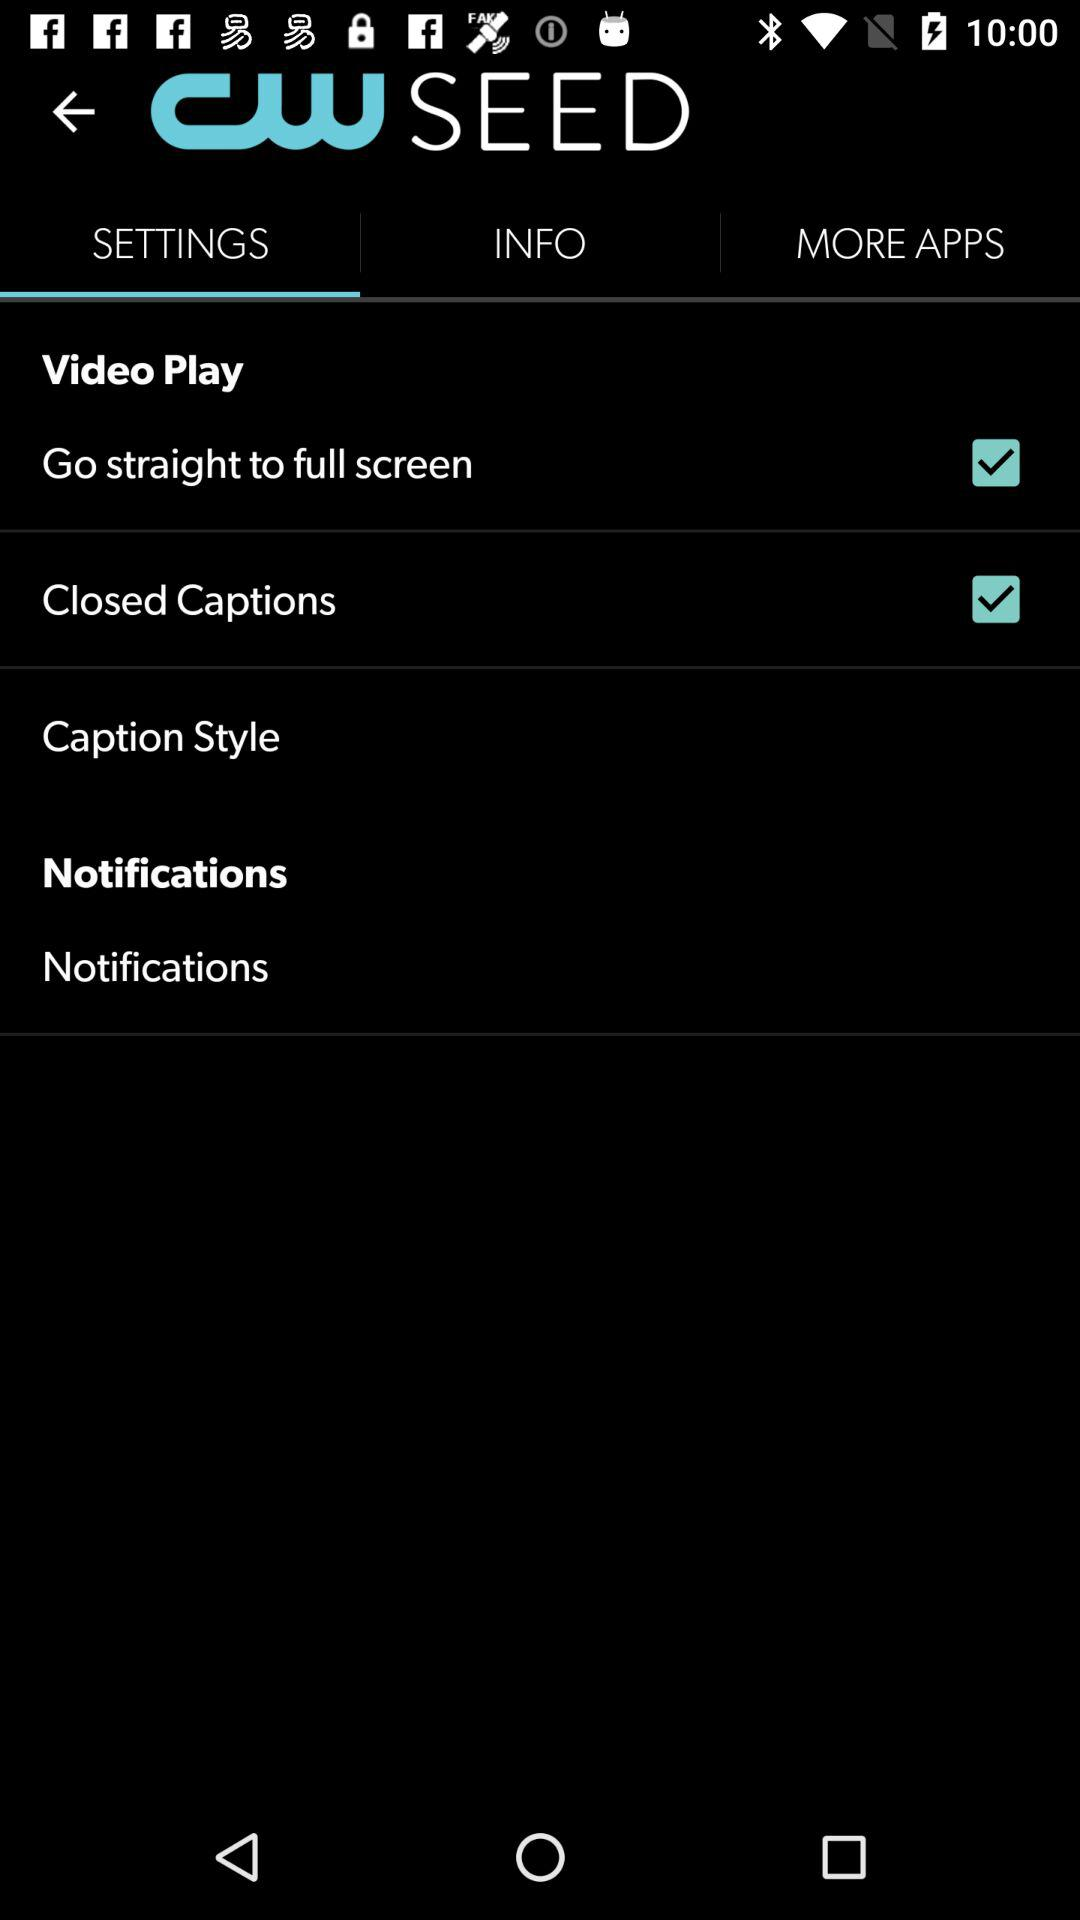Which tab is selected? The selected tab is "SETTINGS". 